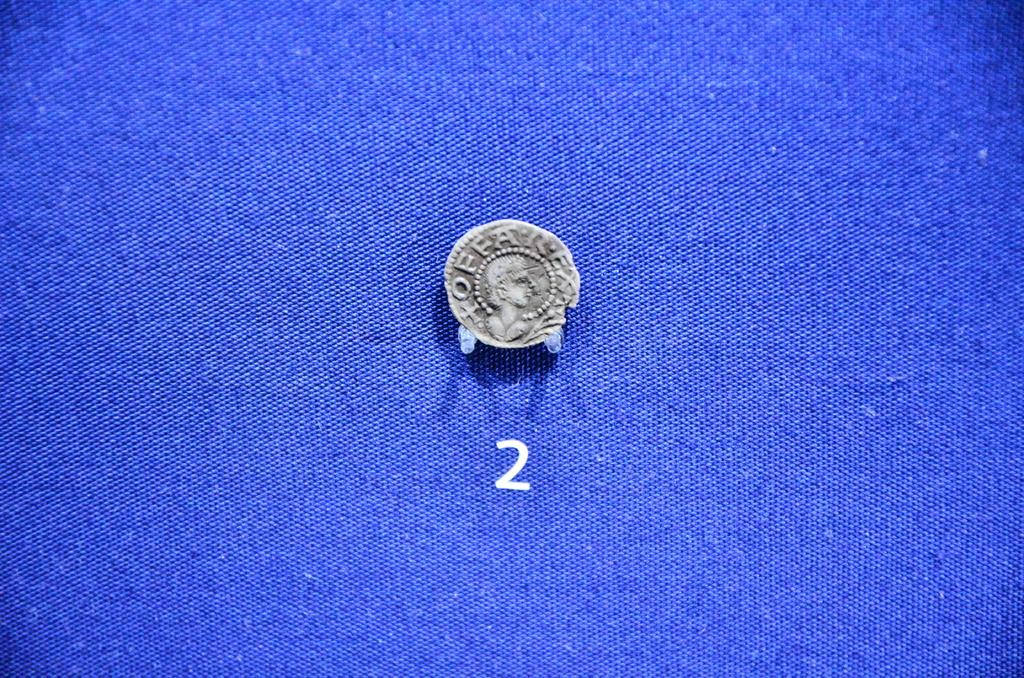<image>
Write a terse but informative summary of the picture. A coin appears on a blue surface above the number 2. 